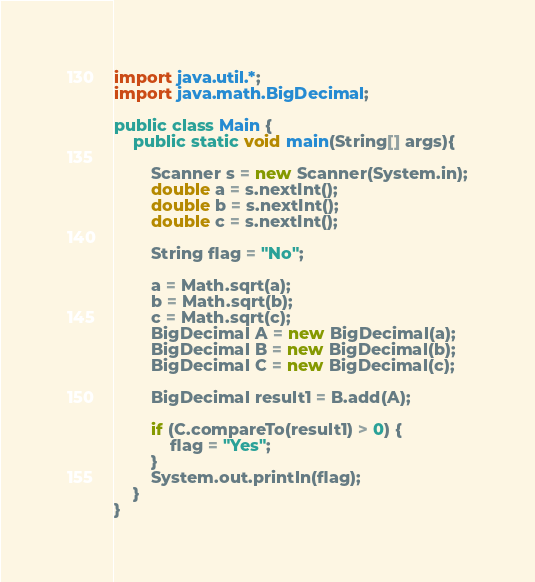Convert code to text. <code><loc_0><loc_0><loc_500><loc_500><_Java_>import java.util.*;
import java.math.BigDecimal;

public class Main {
    public static void main(String[] args){

        Scanner s = new Scanner(System.in);
        double a = s.nextInt();
        double b = s.nextInt();
        double c = s.nextInt();

        String flag = "No";

        a = Math.sqrt(a);
        b = Math.sqrt(b);
        c = Math.sqrt(c);
        BigDecimal A = new BigDecimal(a);
        BigDecimal B = new BigDecimal(b);
        BigDecimal C = new BigDecimal(c);

        BigDecimal result1 = B.add(A);
        
        if (C.compareTo(result1) > 0) {
            flag = "Yes";
        }
        System.out.println(flag);
    }
}</code> 